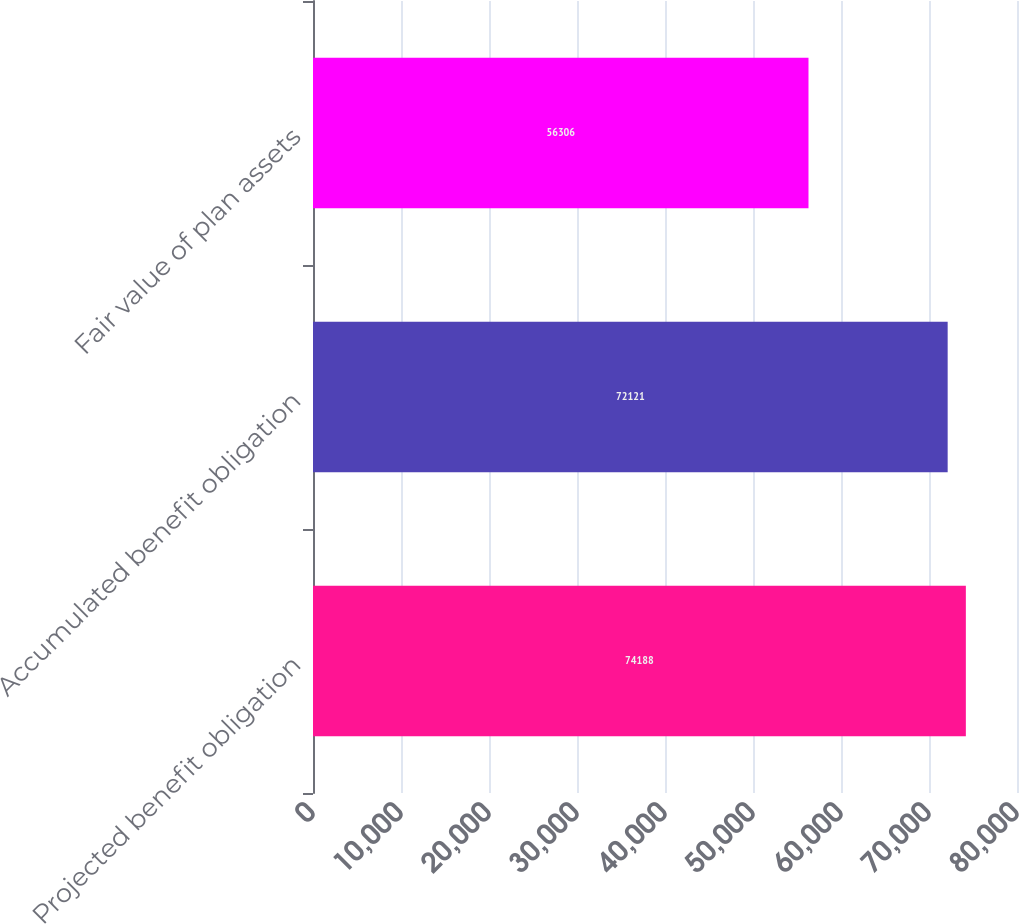Convert chart to OTSL. <chart><loc_0><loc_0><loc_500><loc_500><bar_chart><fcel>Projected benefit obligation<fcel>Accumulated benefit obligation<fcel>Fair value of plan assets<nl><fcel>74188<fcel>72121<fcel>56306<nl></chart> 